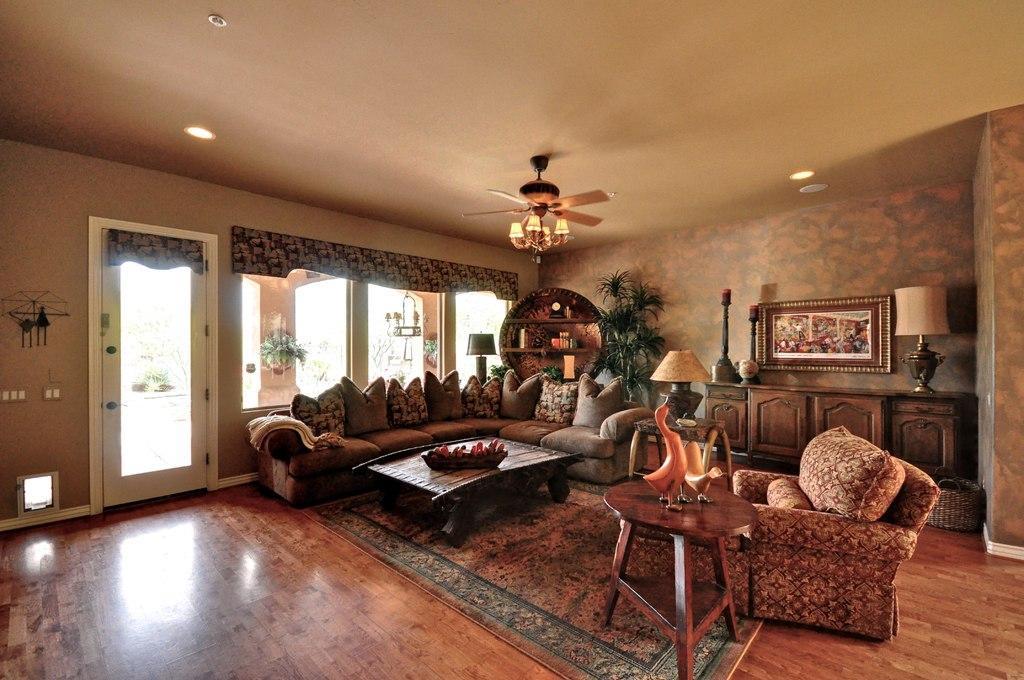Can you describe this image briefly? In this image we can see the inner view of a room. In the room there are sofa set, couch, decors on the side table, table lamp, ceiling fan, electric lights and a carpet on the floor. 